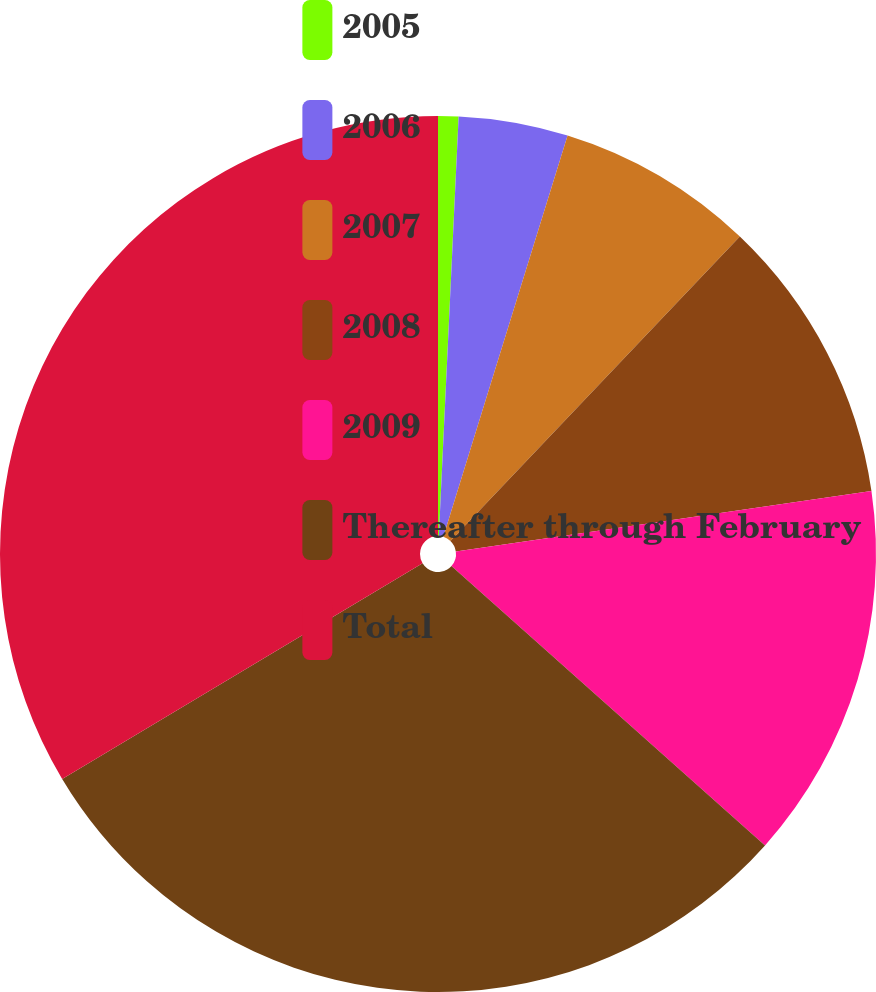Convert chart. <chart><loc_0><loc_0><loc_500><loc_500><pie_chart><fcel>2005<fcel>2006<fcel>2007<fcel>2008<fcel>2009<fcel>Thereafter through February<fcel>Total<nl><fcel>0.75%<fcel>4.03%<fcel>7.32%<fcel>10.6%<fcel>13.88%<fcel>29.83%<fcel>33.58%<nl></chart> 